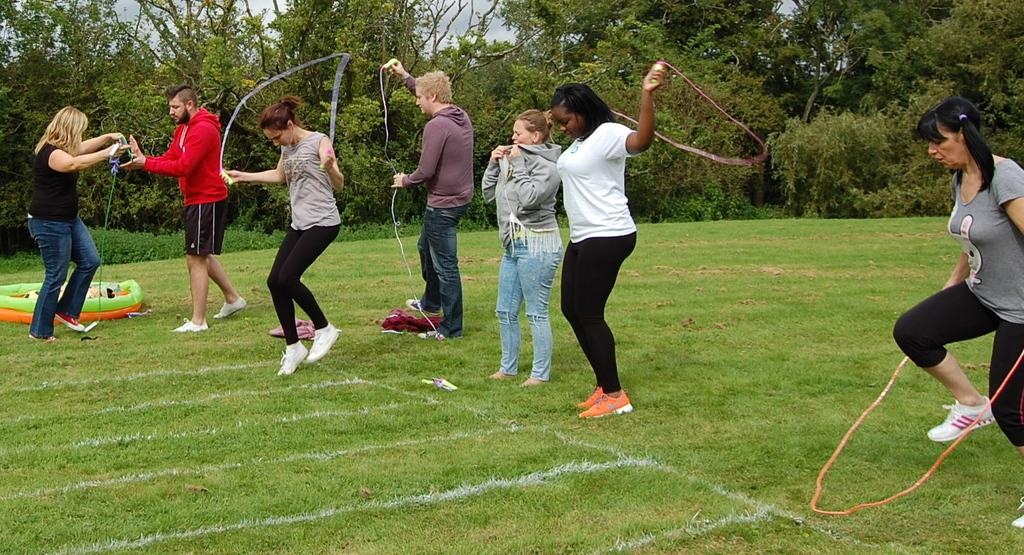What is happening in the image involving a group of people? Some people are skipping with ropes in the image. What can be seen in the background of the image? There are trees and the sky visible in the background of the image. What type of protest is taking place in the image? There is no protest present in the image; it features a group of people skipping with ropes. Can you see the moon in the image? The image does not show the moon; it only features the sky in the background. 